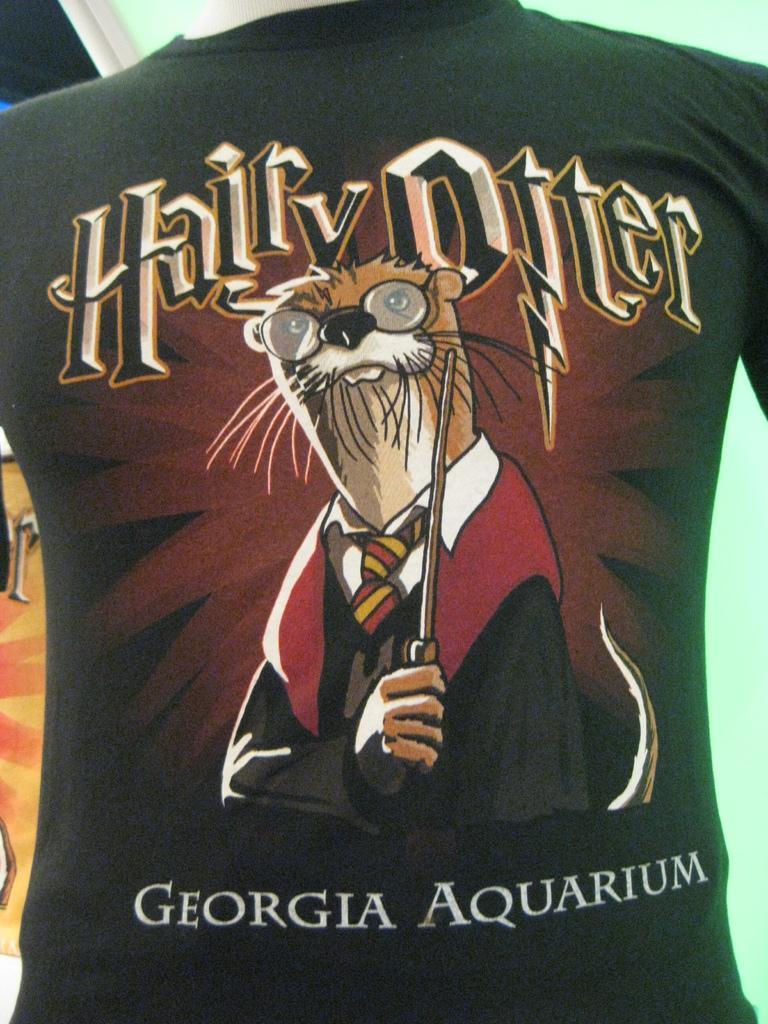How would you summarize this image in a sentence or two? In the center of the image there is a black color t-shirt with some text. 